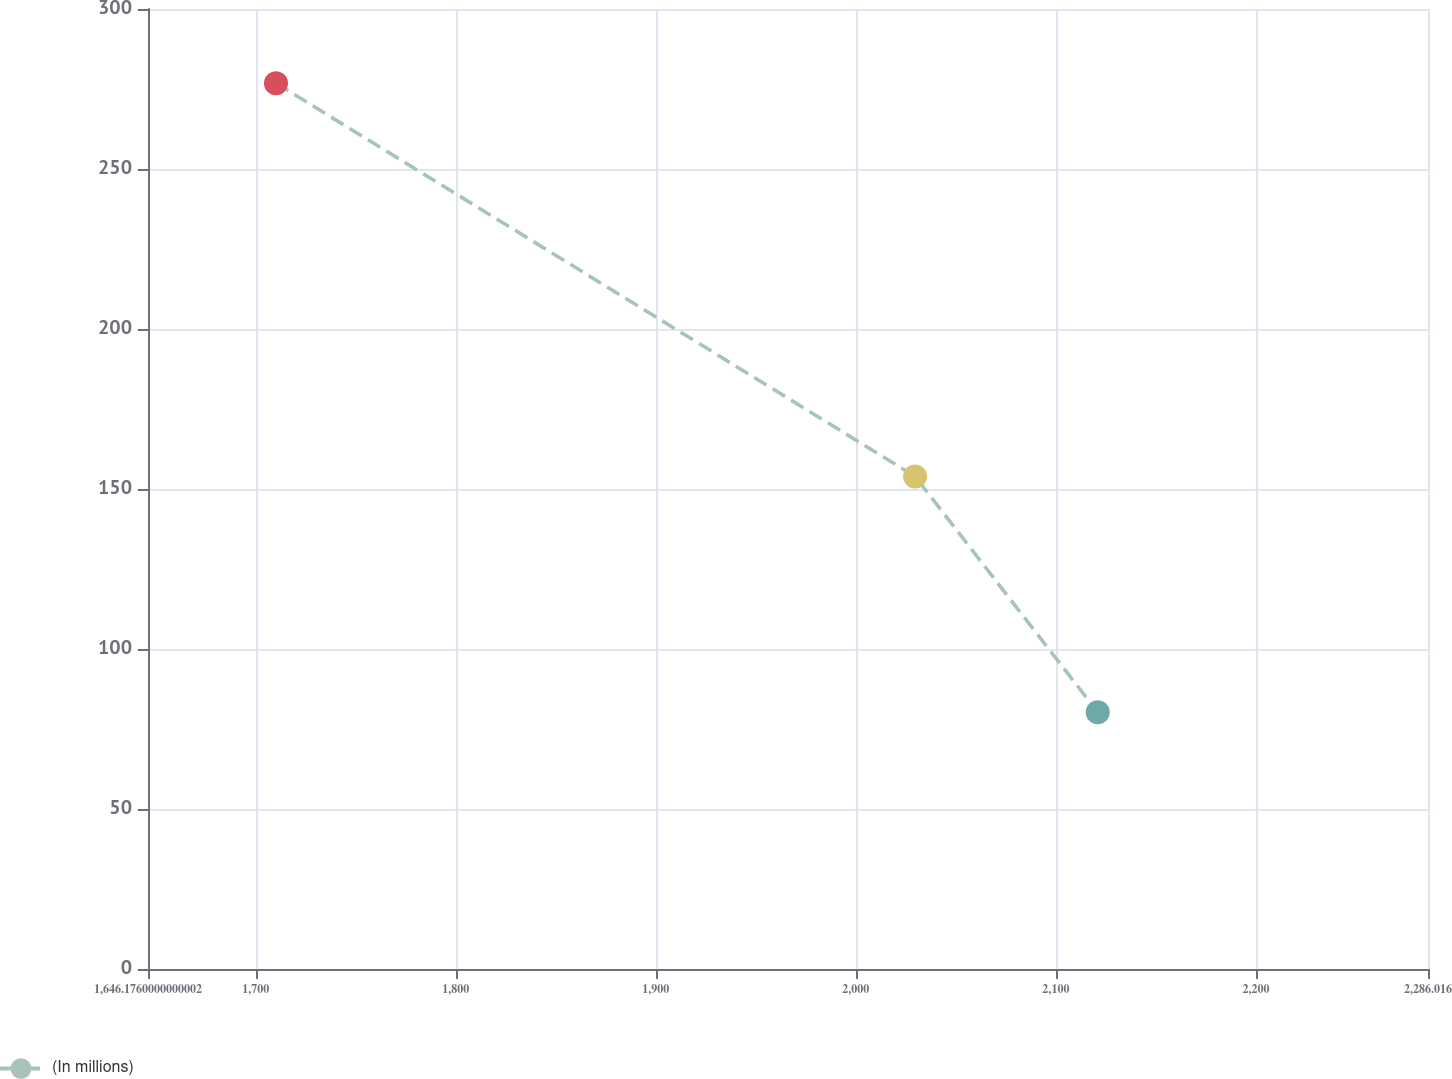<chart> <loc_0><loc_0><loc_500><loc_500><line_chart><ecel><fcel>(In millions)<nl><fcel>1710.16<fcel>276.83<nl><fcel>2029.63<fcel>153.91<nl><fcel>2120.93<fcel>80.25<nl><fcel>2289.14<fcel>102.09<nl><fcel>2350<fcel>58.41<nl></chart> 